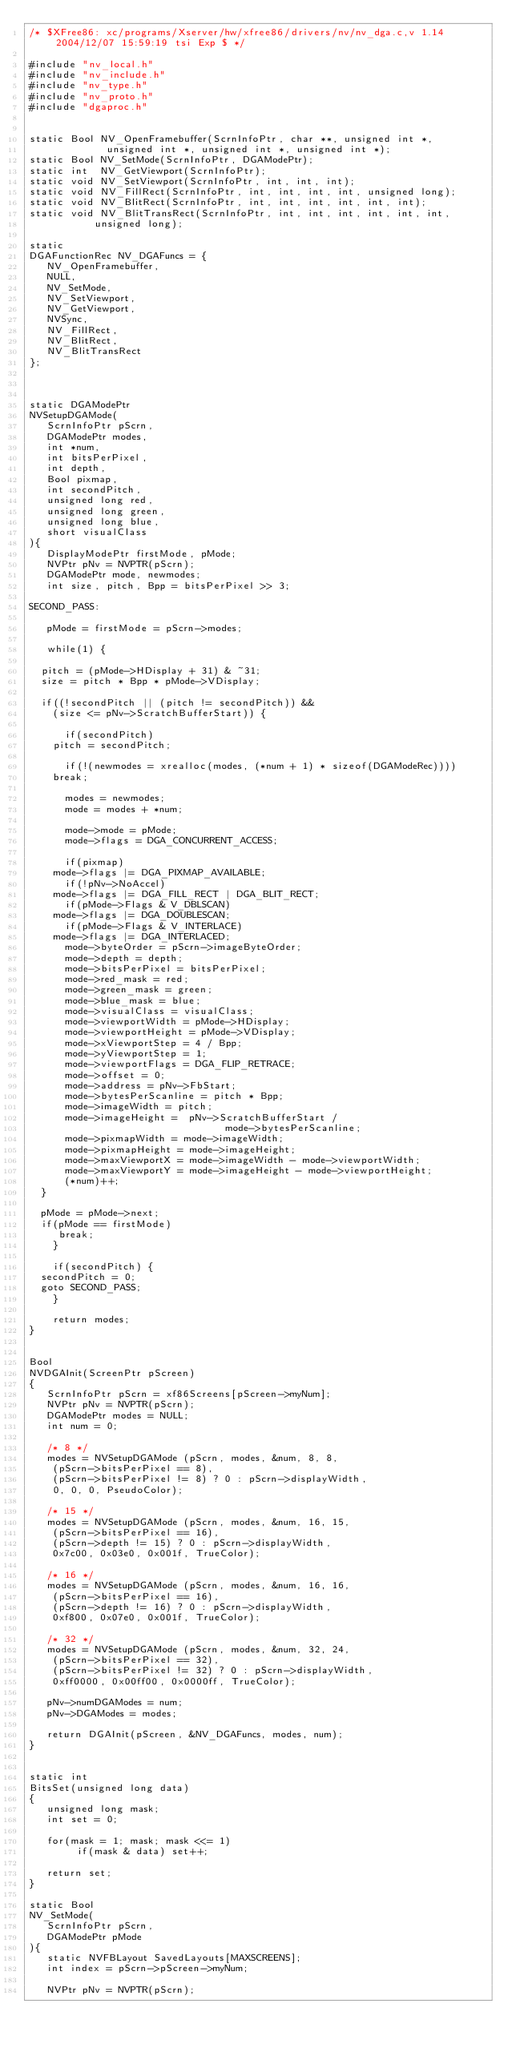Convert code to text. <code><loc_0><loc_0><loc_500><loc_500><_C_>/* $XFree86: xc/programs/Xserver/hw/xfree86/drivers/nv/nv_dga.c,v 1.14 2004/12/07 15:59:19 tsi Exp $ */

#include "nv_local.h"
#include "nv_include.h"
#include "nv_type.h"
#include "nv_proto.h"
#include "dgaproc.h"


static Bool NV_OpenFramebuffer(ScrnInfoPtr, char **, unsigned int *, 
			       unsigned int *, unsigned int *, unsigned int *);
static Bool NV_SetMode(ScrnInfoPtr, DGAModePtr);
static int  NV_GetViewport(ScrnInfoPtr);
static void NV_SetViewport(ScrnInfoPtr, int, int, int);
static void NV_FillRect(ScrnInfoPtr, int, int, int, int, unsigned long);
static void NV_BlitRect(ScrnInfoPtr, int, int, int, int, int, int);
static void NV_BlitTransRect(ScrnInfoPtr, int, int, int, int, int, int, 
			     unsigned long);

static
DGAFunctionRec NV_DGAFuncs = {
   NV_OpenFramebuffer,
   NULL,
   NV_SetMode,
   NV_SetViewport,
   NV_GetViewport,
   NVSync,
   NV_FillRect,
   NV_BlitRect,
   NV_BlitTransRect
};



static DGAModePtr
NVSetupDGAMode(
   ScrnInfoPtr pScrn,
   DGAModePtr modes,
   int *num,
   int bitsPerPixel,
   int depth,
   Bool pixmap,
   int secondPitch,
   unsigned long red,
   unsigned long green,
   unsigned long blue,
   short visualClass
){
   DisplayModePtr firstMode, pMode;
   NVPtr pNv = NVPTR(pScrn);
   DGAModePtr mode, newmodes;
   int size, pitch, Bpp = bitsPerPixel >> 3;

SECOND_PASS:

   pMode = firstMode = pScrn->modes;

   while(1) {

	pitch = (pMode->HDisplay + 31) & ~31;
	size = pitch * Bpp * pMode->VDisplay;

	if((!secondPitch || (pitch != secondPitch)) &&
		(size <= pNv->ScratchBufferStart)) {

	    if(secondPitch)
		pitch = secondPitch; 

	    if(!(newmodes = xrealloc(modes, (*num + 1) * sizeof(DGAModeRec))))
		break;

	    modes = newmodes;
	    mode = modes + *num;

	    mode->mode = pMode;
	    mode->flags = DGA_CONCURRENT_ACCESS;

	    if(pixmap)
		mode->flags |= DGA_PIXMAP_AVAILABLE;
	    if(!pNv->NoAccel)
		mode->flags |= DGA_FILL_RECT | DGA_BLIT_RECT;
	    if(pMode->Flags & V_DBLSCAN)
		mode->flags |= DGA_DOUBLESCAN;
	    if(pMode->Flags & V_INTERLACE)
		mode->flags |= DGA_INTERLACED;
	    mode->byteOrder = pScrn->imageByteOrder;
	    mode->depth = depth;
	    mode->bitsPerPixel = bitsPerPixel;
	    mode->red_mask = red;
	    mode->green_mask = green;
	    mode->blue_mask = blue;
	    mode->visualClass = visualClass;
	    mode->viewportWidth = pMode->HDisplay;
	    mode->viewportHeight = pMode->VDisplay;
	    mode->xViewportStep = 4 / Bpp;
	    mode->yViewportStep = 1;
	    mode->viewportFlags = DGA_FLIP_RETRACE;
	    mode->offset = 0;
	    mode->address = pNv->FbStart;
	    mode->bytesPerScanline = pitch * Bpp;
	    mode->imageWidth = pitch;
	    mode->imageHeight =  pNv->ScratchBufferStart / 
                                 mode->bytesPerScanline; 
	    mode->pixmapWidth = mode->imageWidth;
	    mode->pixmapHeight = mode->imageHeight;
	    mode->maxViewportX = mode->imageWidth - mode->viewportWidth;
	    mode->maxViewportY = mode->imageHeight - mode->viewportHeight;
	    (*num)++;
	}

	pMode = pMode->next;
	if(pMode == firstMode)
	   break;
    }

    if(secondPitch) {
	secondPitch = 0;
	goto SECOND_PASS;
    }

    return modes;
}


Bool
NVDGAInit(ScreenPtr pScreen)
{   
   ScrnInfoPtr pScrn = xf86Screens[pScreen->myNum];
   NVPtr pNv = NVPTR(pScrn);
   DGAModePtr modes = NULL;
   int num = 0;

   /* 8 */
   modes = NVSetupDGAMode (pScrn, modes, &num, 8, 8, 
		(pScrn->bitsPerPixel == 8),
		(pScrn->bitsPerPixel != 8) ? 0 : pScrn->displayWidth,
		0, 0, 0, PseudoColor);

   /* 15 */
   modes = NVSetupDGAMode (pScrn, modes, &num, 16, 15, 
		(pScrn->bitsPerPixel == 16),
		(pScrn->depth != 15) ? 0 : pScrn->displayWidth,
		0x7c00, 0x03e0, 0x001f, TrueColor);

   /* 16 */
   modes = NVSetupDGAMode (pScrn, modes, &num, 16, 16, 
		(pScrn->bitsPerPixel == 16),
		(pScrn->depth != 16) ? 0 : pScrn->displayWidth,
		0xf800, 0x07e0, 0x001f, TrueColor);

   /* 32 */
   modes = NVSetupDGAMode (pScrn, modes, &num, 32, 24, 
		(pScrn->bitsPerPixel == 32),
		(pScrn->bitsPerPixel != 32) ? 0 : pScrn->displayWidth,
		0xff0000, 0x00ff00, 0x0000ff, TrueColor);

   pNv->numDGAModes = num;
   pNv->DGAModes = modes;

   return DGAInit(pScreen, &NV_DGAFuncs, modes, num);  
}


static int 
BitsSet(unsigned long data)
{
   unsigned long mask;
   int set = 0;

   for(mask = 1; mask; mask <<= 1)
        if(mask & data) set++;   

   return set;
}

static Bool
NV_SetMode(
   ScrnInfoPtr pScrn,
   DGAModePtr pMode
){
   static NVFBLayout SavedLayouts[MAXSCREENS];
   int index = pScrn->pScreen->myNum;

   NVPtr pNv = NVPTR(pScrn);
</code> 